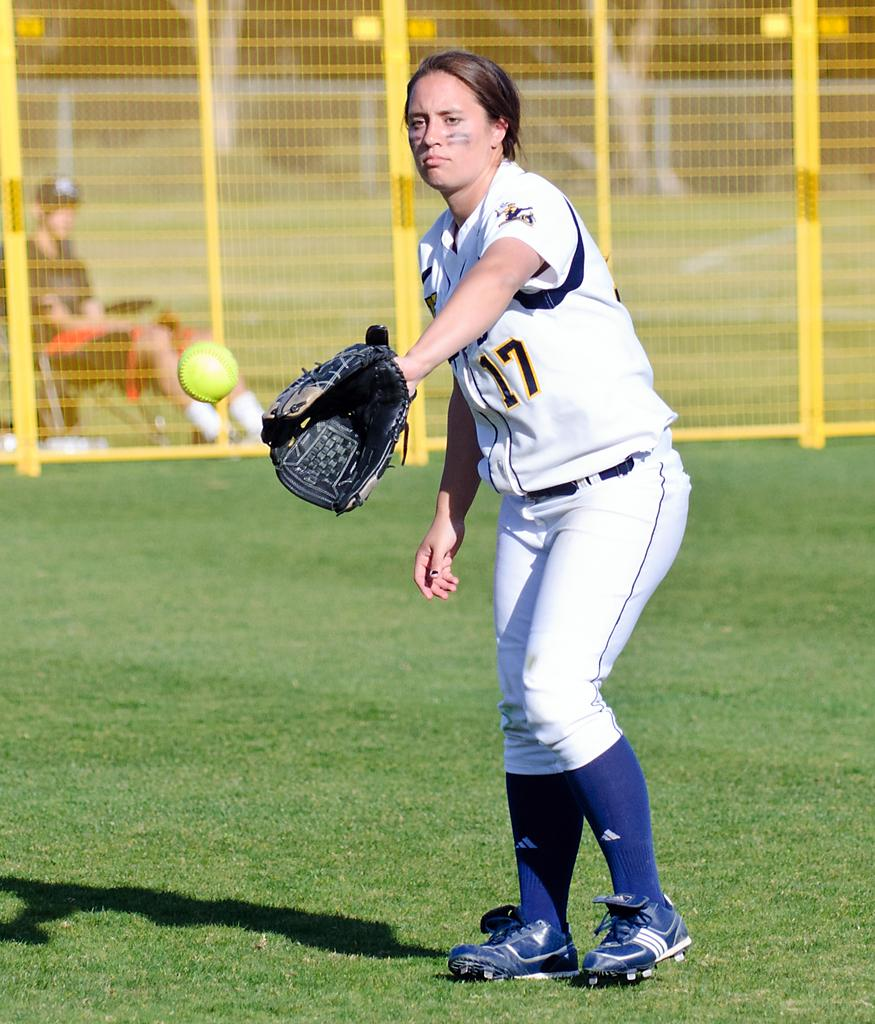Provide a one-sentence caption for the provided image. The girl player wears the number 17 shirt. 